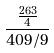Convert formula to latex. <formula><loc_0><loc_0><loc_500><loc_500>\frac { \frac { 2 6 3 } { 4 } } { 4 0 9 / 9 }</formula> 